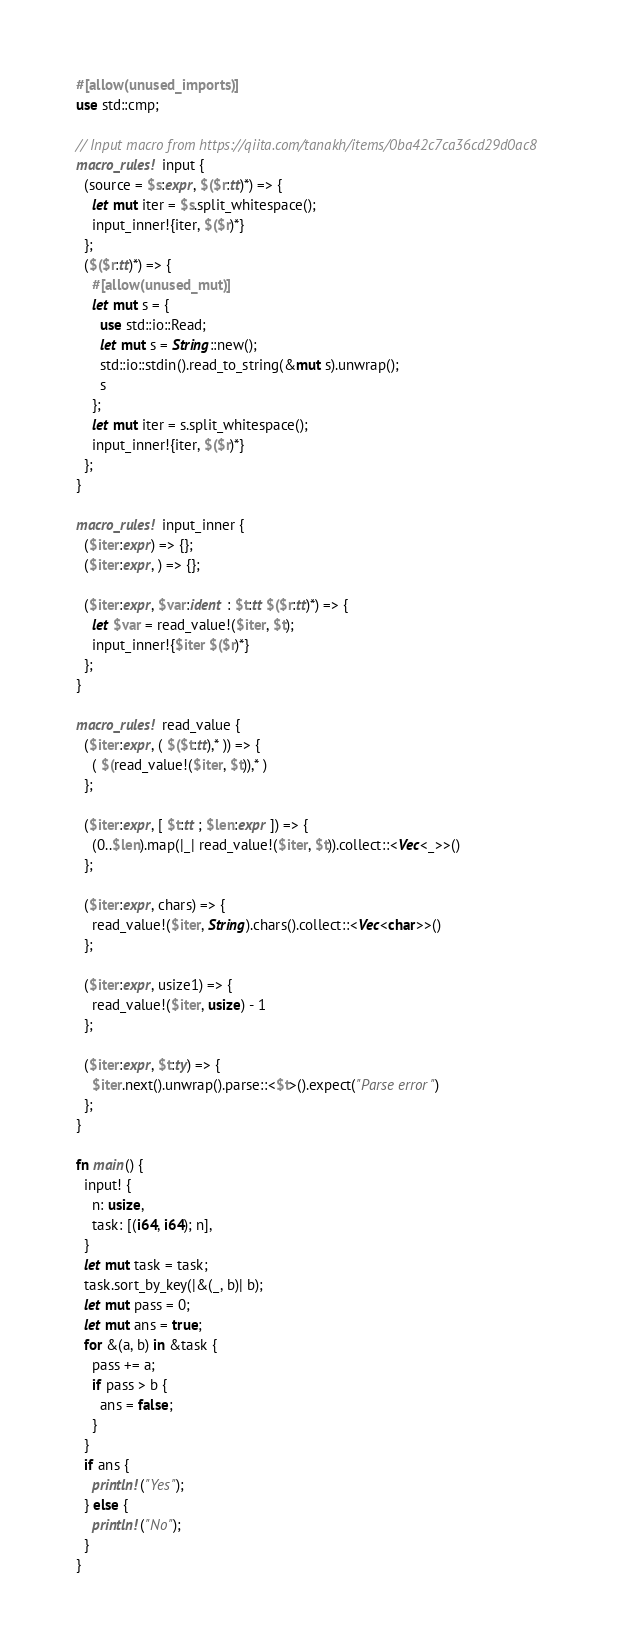Convert code to text. <code><loc_0><loc_0><loc_500><loc_500><_Rust_>#[allow(unused_imports)]
use std::cmp;

// Input macro from https://qiita.com/tanakh/items/0ba42c7ca36cd29d0ac8
macro_rules! input {
  (source = $s:expr, $($r:tt)*) => {
    let mut iter = $s.split_whitespace();
    input_inner!{iter, $($r)*}
  };
  ($($r:tt)*) => {
    #[allow(unused_mut)]
    let mut s = {
      use std::io::Read;
      let mut s = String::new();
      std::io::stdin().read_to_string(&mut s).unwrap();
      s
    };
    let mut iter = s.split_whitespace();
    input_inner!{iter, $($r)*}
  };
}

macro_rules! input_inner {
  ($iter:expr) => {};
  ($iter:expr, ) => {};

  ($iter:expr, $var:ident : $t:tt $($r:tt)*) => {
    let $var = read_value!($iter, $t);
    input_inner!{$iter $($r)*}
  };
}

macro_rules! read_value {
  ($iter:expr, ( $($t:tt),* )) => {
    ( $(read_value!($iter, $t)),* )
  };

  ($iter:expr, [ $t:tt ; $len:expr ]) => {
    (0..$len).map(|_| read_value!($iter, $t)).collect::<Vec<_>>()
  };

  ($iter:expr, chars) => {
    read_value!($iter, String).chars().collect::<Vec<char>>()
  };

  ($iter:expr, usize1) => {
    read_value!($iter, usize) - 1
  };

  ($iter:expr, $t:ty) => {
    $iter.next().unwrap().parse::<$t>().expect("Parse error")
  };
}

fn main() {
  input! {
    n: usize,
    task: [(i64, i64); n],
  }
  let mut task = task;
  task.sort_by_key(|&(_, b)| b);
  let mut pass = 0;
  let mut ans = true;
  for &(a, b) in &task {
    pass += a;
    if pass > b {
      ans = false;
    }
  }
  if ans {
    println!("Yes");
  } else {
    println!("No");
  }
}
</code> 